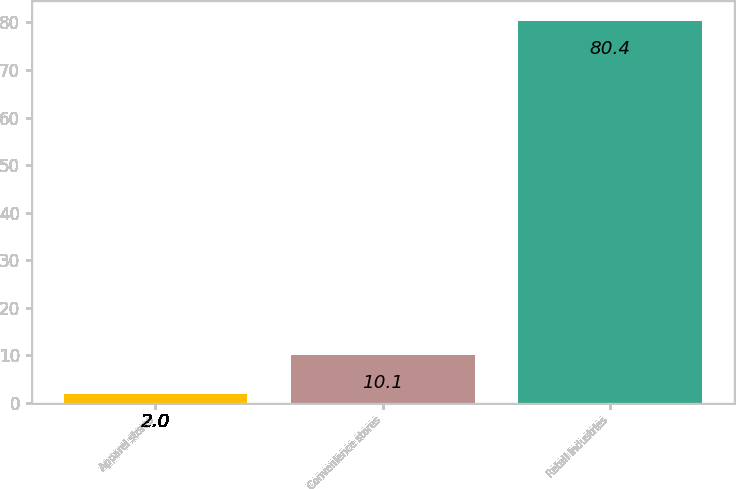Convert chart. <chart><loc_0><loc_0><loc_500><loc_500><bar_chart><fcel>Apparel stores<fcel>Convenience stores<fcel>Retail industries<nl><fcel>2<fcel>10.1<fcel>80.4<nl></chart> 